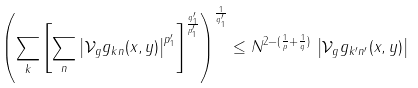<formula> <loc_0><loc_0><loc_500><loc_500>\left ( \sum _ { k } \left [ \sum _ { n } \left | \mathcal { V } _ { g } g _ { k n } ( x , y ) \right | ^ { p ^ { \prime } _ { 1 } } \right ] ^ { \frac { q ^ { \prime } _ { 1 } } { p ^ { \prime } _ { 1 } } } \right ) ^ { \frac { 1 } { q ^ { \prime } _ { 1 } } } \leq N ^ { 2 - ( \frac { 1 } { p } + \frac { 1 } { q } ) } \, \left | \mathcal { V } _ { g } g _ { k ^ { \prime } n ^ { \prime } } ( x , y ) \right |</formula> 